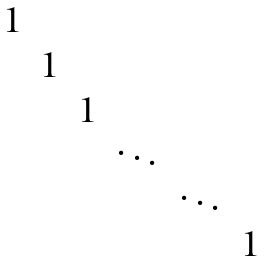Convert formula to latex. <formula><loc_0><loc_0><loc_500><loc_500>\begin{matrix} 1 & & & & \\ & 1 & & & \\ & & 1 & & \\ & & & \ddots & & \\ & & & & \ddots & \\ & & & & & 1 \end{matrix}</formula> 